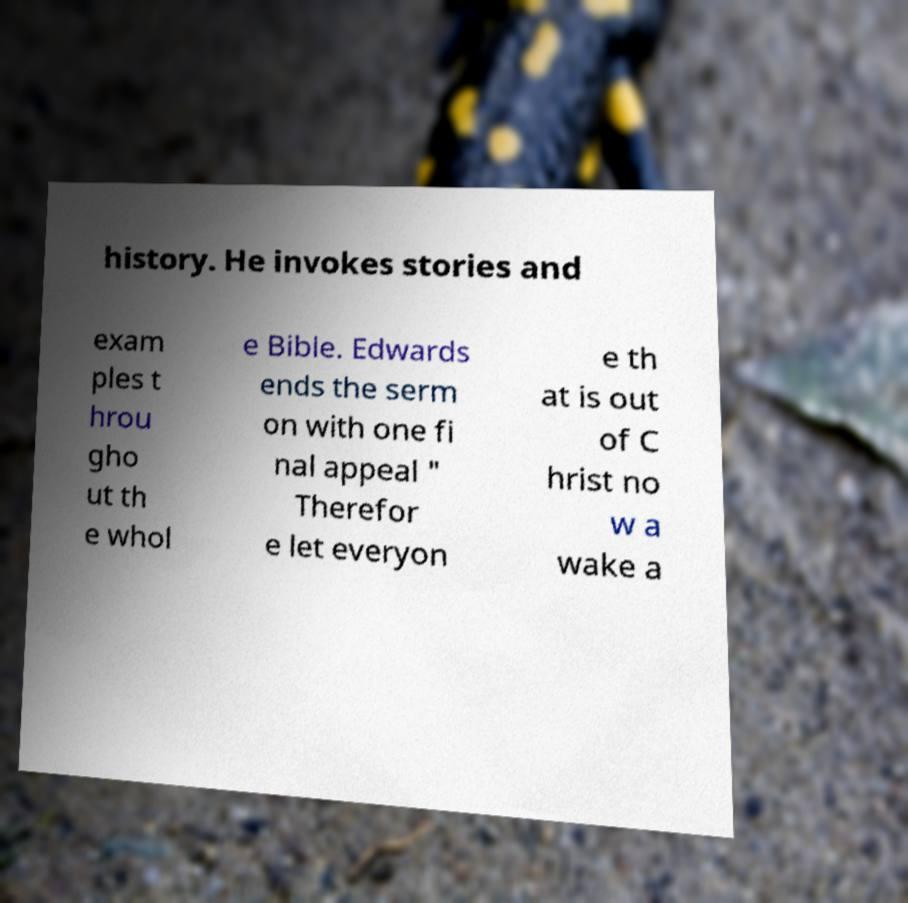Please read and relay the text visible in this image. What does it say? history. He invokes stories and exam ples t hrou gho ut th e whol e Bible. Edwards ends the serm on with one fi nal appeal " Therefor e let everyon e th at is out of C hrist no w a wake a 